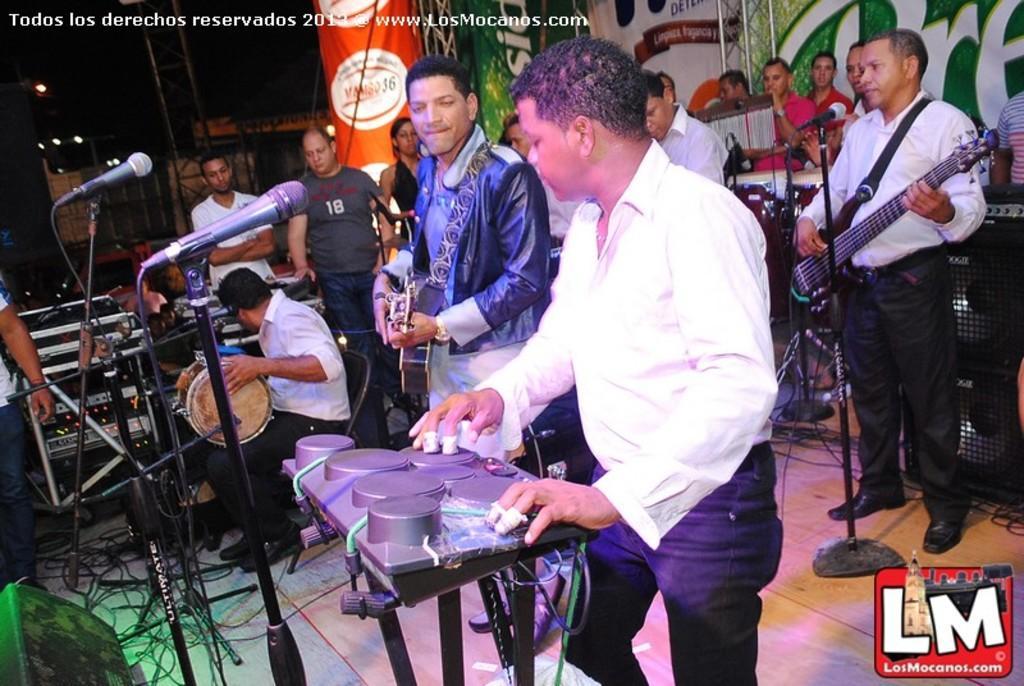How would you summarize this image in a sentence or two? In a picture there are many people two people are playing guitar one person is sitting and playing drums and another person is playing musical instruments there are many people watching them there are musical sound systems there are banners near to them there are many poles near to them. 